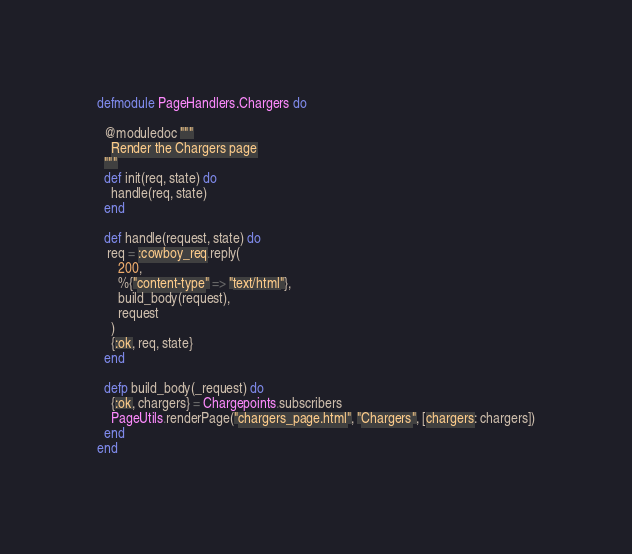Convert code to text. <code><loc_0><loc_0><loc_500><loc_500><_Elixir_>defmodule PageHandlers.Chargers do

  @moduledoc """
    Render the Chargers page
  """
  def init(req, state) do
    handle(req, state)
  end

  def handle(request, state) do
   req = :cowboy_req.reply(
      200,
      %{"content-type" => "text/html"},
      build_body(request),
      request
    )
    {:ok, req, state}
  end

  defp build_body(_request) do
    {:ok, chargers} = Chargepoints.subscribers
  	PageUtils.renderPage("chargers_page.html", "Chargers", [chargers: chargers])
  end
end
</code> 